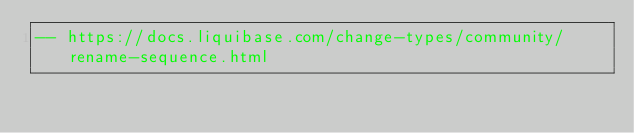Convert code to text. <code><loc_0><loc_0><loc_500><loc_500><_SQL_>-- https://docs.liquibase.com/change-types/community/rename-sequence.html</code> 